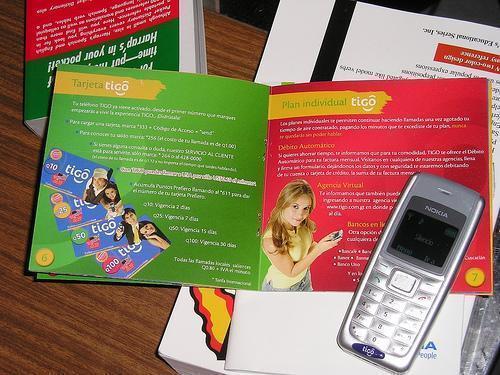What is the silver device on the red paper used for?
Answer the question by selecting the correct answer among the 4 following choices.
Options: Paper weight, making calls, blending food, cracking nuts. Making calls. 